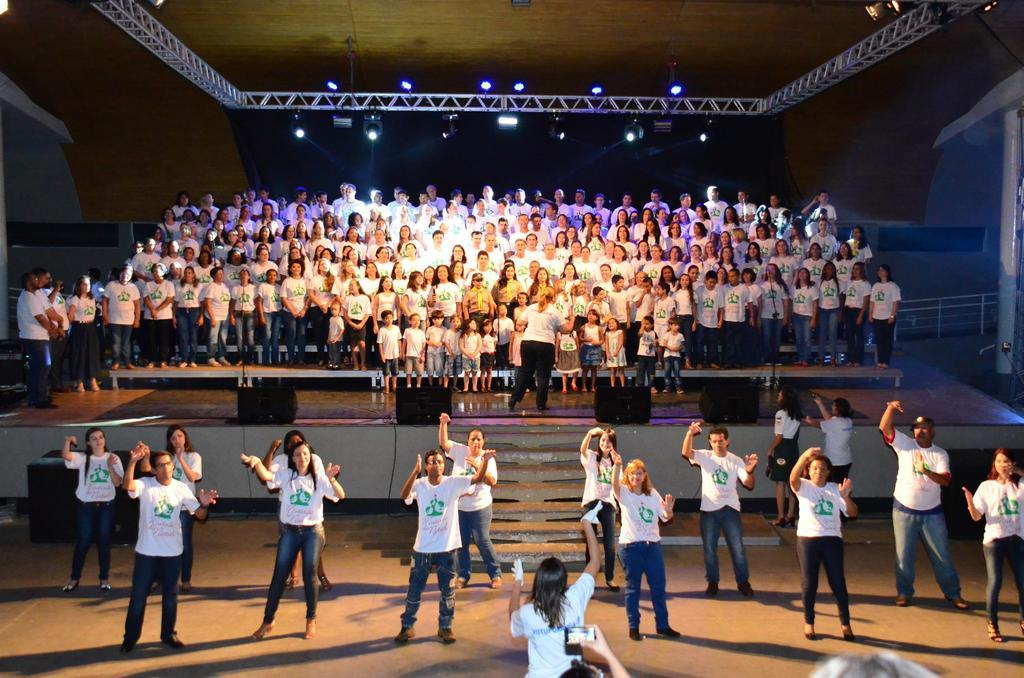What are the people in the image doing? There is a group of people standing on the stage, and there are persons dancing on the floor. What can be seen in the background of the image? There are lights and a pole in the background. What sound does the kitty make while sitting on the pole in the image? There is no kitty present in the image, so it is not possible to determine what sound it might make. 